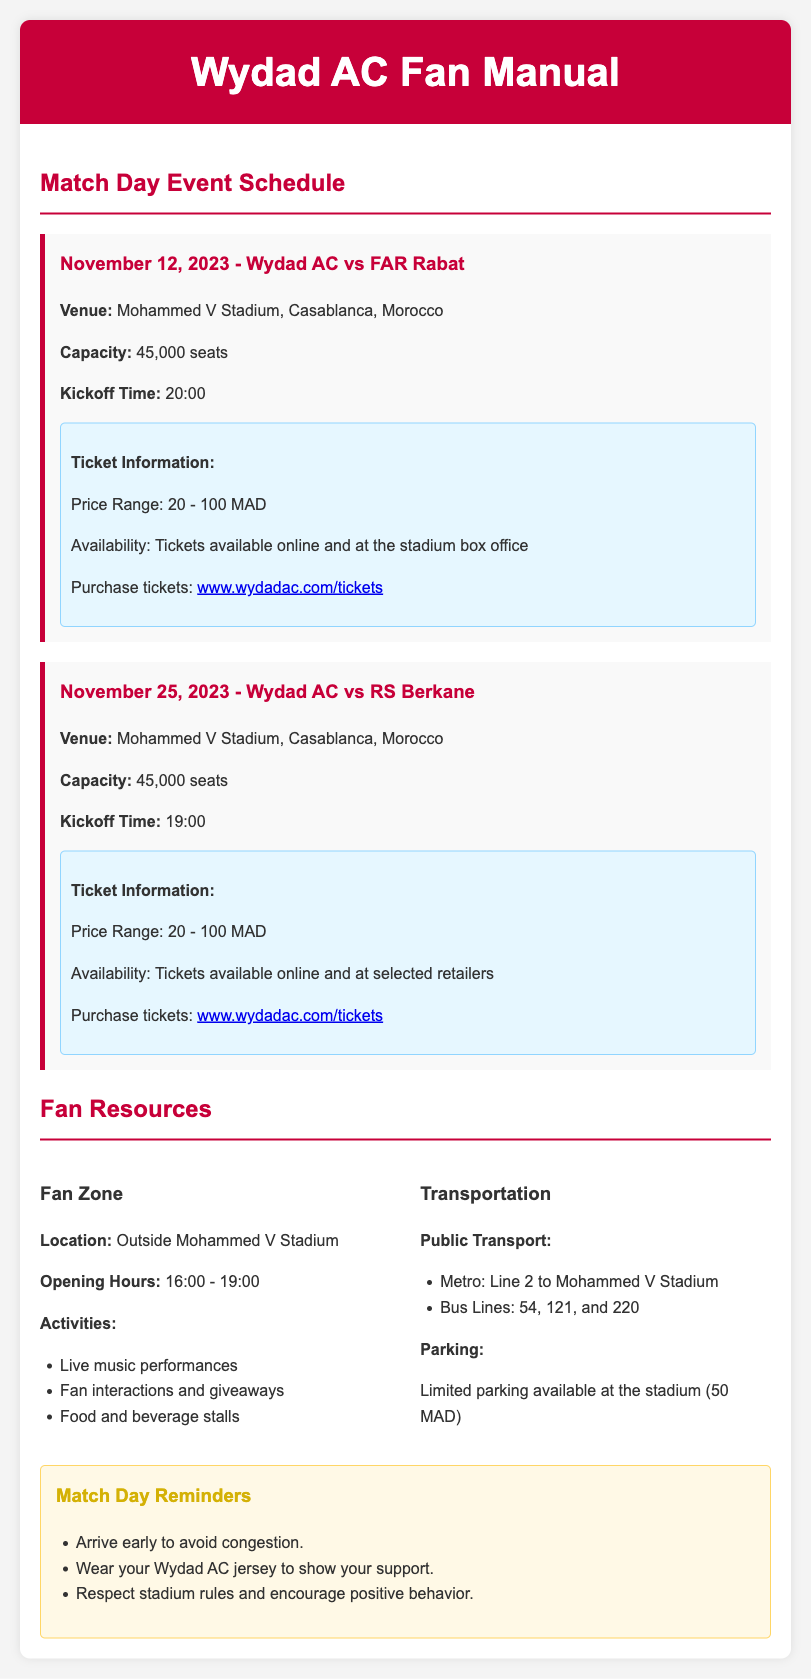What is the date of the match against FAR Rabat? The specific date for the match against FAR Rabat is provided under the match schedule section.
Answer: November 12, 2023 What is the capacity of Mohammed V Stadium? The capacity is mentioned in the venue details for both matches.
Answer: 45,000 seats What time does the match against RS Berkane kick off? The kickoff time for the match against RS Berkane is detailed in the match info.
Answer: 19:00 Where can I purchase Wydad AC match tickets? The ticket purchasing location is mentioned in the ticket information sections for both matches.
Answer: www.wydadac.com/tickets What are the opening hours for the Fan Zone? The Fan Zone's opening hours are listed explicitly in the fan resources section.
Answer: 16:00 - 19:00 How much does parking cost at the stadium? The parking cost is mentioned under the transportation section of the document.
Answer: 50 MAD What activities will be available at the Fan Zone? The activities offered in the Fan Zone are listed, including specific examples.
Answer: Live music performances, Fan interactions and giveaways, Food and beverage stalls How should fans show their support on match day? The document includes a reminder about fan behavior and support.
Answer: Wear your Wydad AC jersey What public transport options are available to reach Mohammed V Stadium? The public transport options are enumerated clearly in the transportation section.
Answer: Metro: Line 2, Bus Lines: 54, 121, and 220 